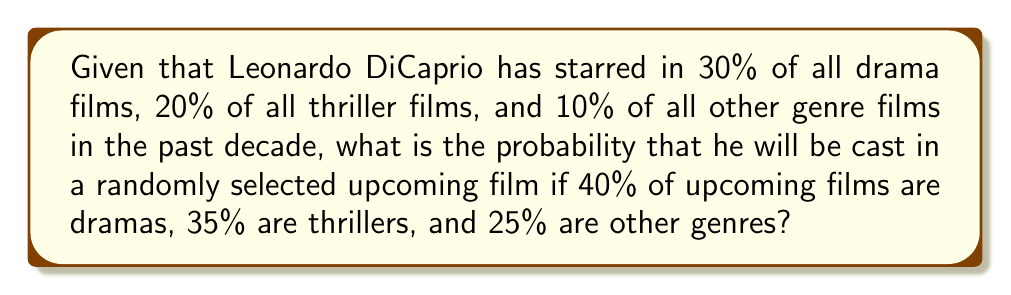Show me your answer to this math problem. Let's approach this step-by-step using the law of total probability:

1) Define events:
   D: The film is a drama
   T: The film is a thriller
   O: The film is another genre
   L: Leonardo DiCaprio is cast

2) Given probabilities:
   P(D) = 0.40
   P(T) = 0.35
   P(O) = 0.25
   P(L|D) = 0.30
   P(L|T) = 0.20
   P(L|O) = 0.10

3) Use the law of total probability:
   $$P(L) = P(L|D)P(D) + P(L|T)P(T) + P(L|O)P(O)$$

4) Substitute the values:
   $$P(L) = (0.30)(0.40) + (0.20)(0.35) + (0.10)(0.25)$$

5) Calculate:
   $$P(L) = 0.12 + 0.07 + 0.025 = 0.215$$

6) Convert to percentage:
   0.215 * 100 = 21.5%
Answer: 21.5% 